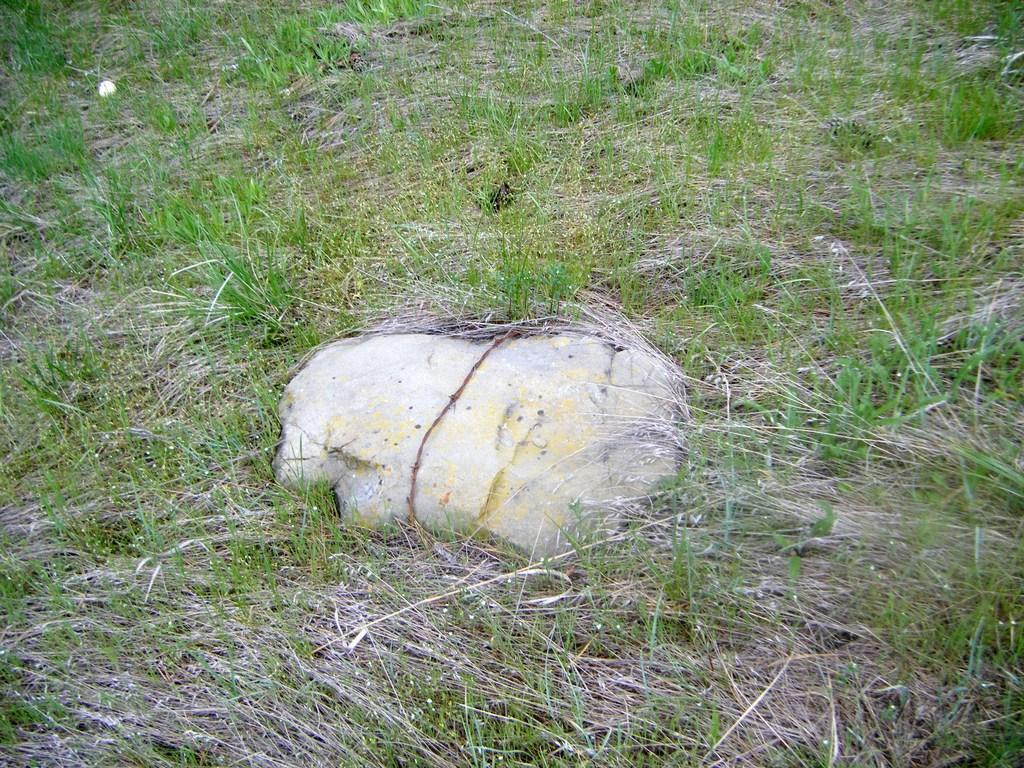Describe this image in one or two sentences. In this picture there is grass and there is a stone. 